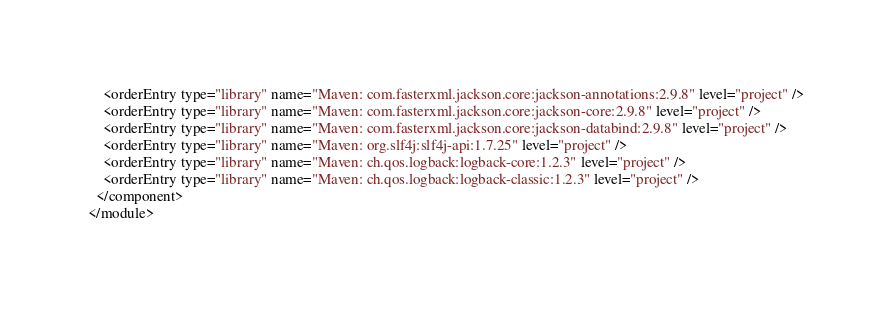Convert code to text. <code><loc_0><loc_0><loc_500><loc_500><_XML_>    <orderEntry type="library" name="Maven: com.fasterxml.jackson.core:jackson-annotations:2.9.8" level="project" />
    <orderEntry type="library" name="Maven: com.fasterxml.jackson.core:jackson-core:2.9.8" level="project" />
    <orderEntry type="library" name="Maven: com.fasterxml.jackson.core:jackson-databind:2.9.8" level="project" />
    <orderEntry type="library" name="Maven: org.slf4j:slf4j-api:1.7.25" level="project" />
    <orderEntry type="library" name="Maven: ch.qos.logback:logback-core:1.2.3" level="project" />
    <orderEntry type="library" name="Maven: ch.qos.logback:logback-classic:1.2.3" level="project" />
  </component>
</module></code> 